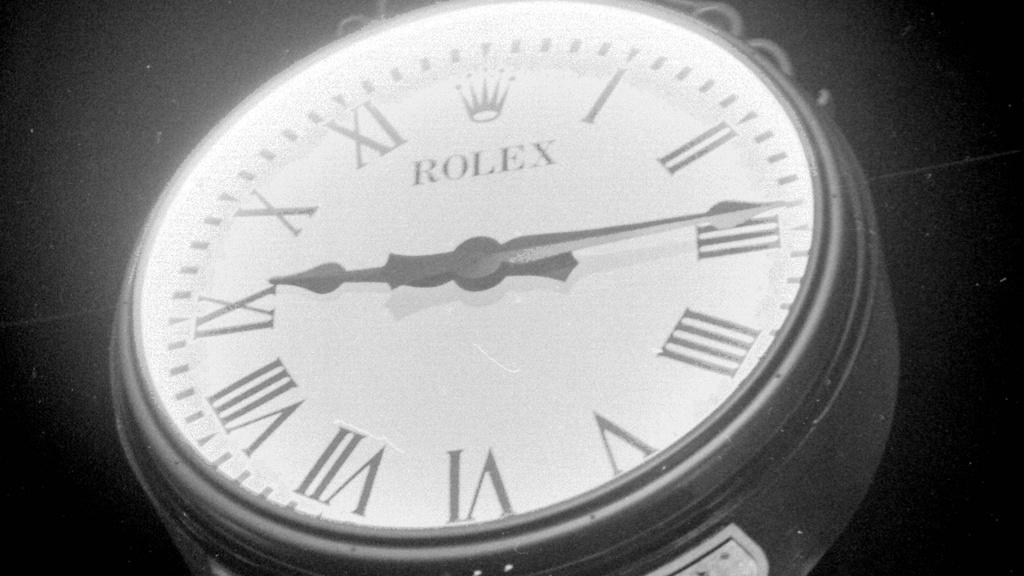<image>
Render a clear and concise summary of the photo. A Rolex which has Roman numerals set at quarter past nine. 